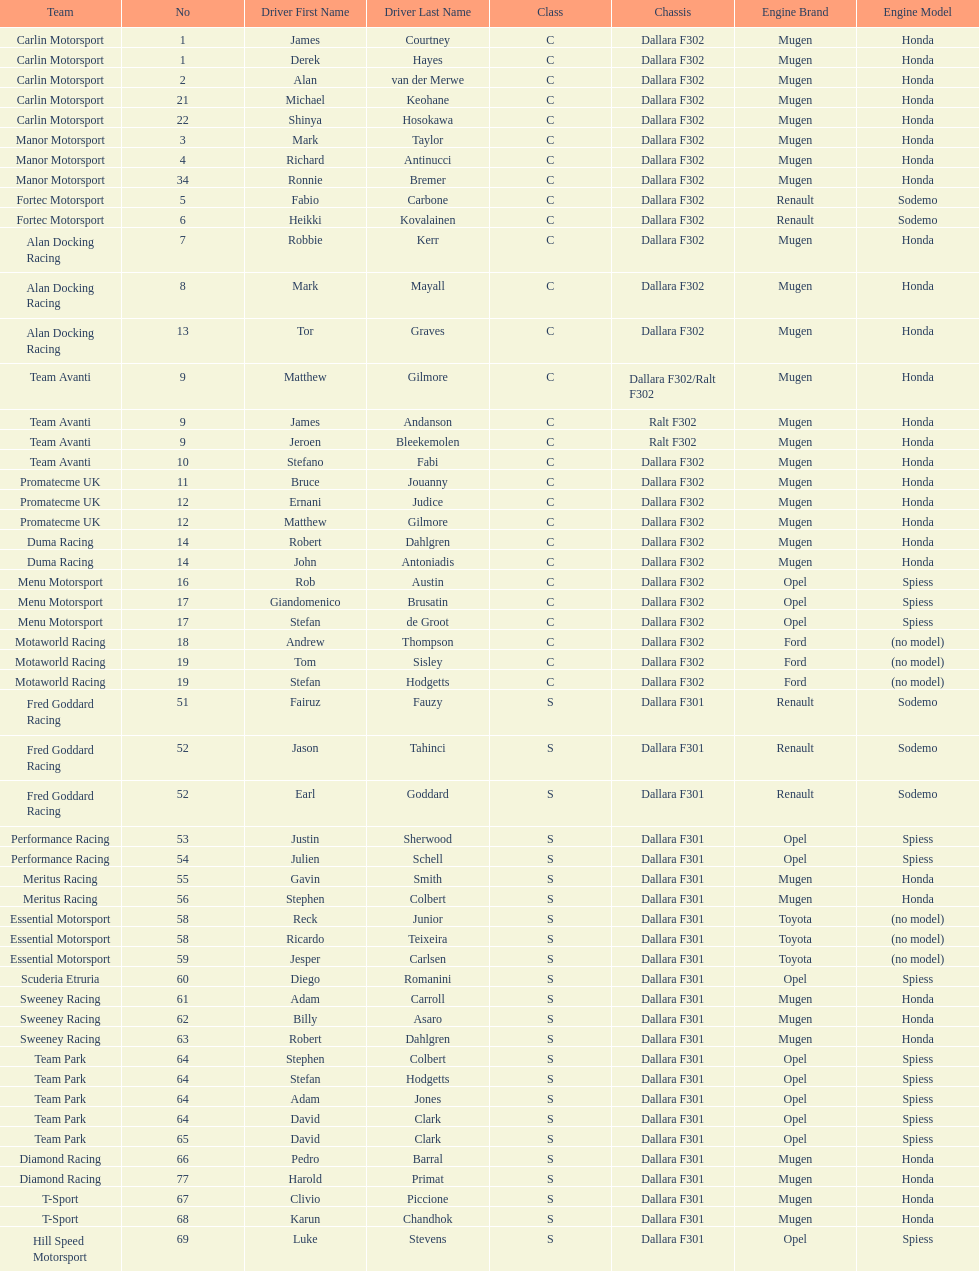What team is listed above diamond racing? Team Park. 